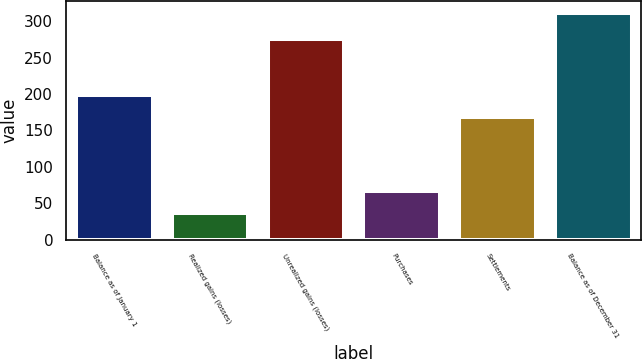Convert chart to OTSL. <chart><loc_0><loc_0><loc_500><loc_500><bar_chart><fcel>Balance as of January 1<fcel>Realized gains (losses)<fcel>Unrealized gains (losses)<fcel>Purchases<fcel>Settlements<fcel>Balance as of December 31<nl><fcel>198.6<fcel>36.6<fcel>275<fcel>67.2<fcel>168<fcel>312<nl></chart> 